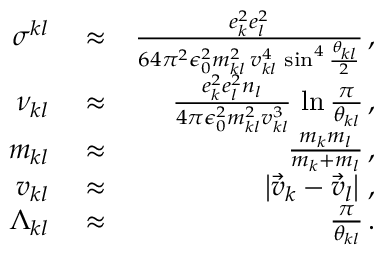<formula> <loc_0><loc_0><loc_500><loc_500>\begin{array} { r l r } { \sigma ^ { k l } } & \approx } & { \frac { e _ { k } ^ { 2 } e _ { l } ^ { 2 } } { 6 4 \pi ^ { 2 } \epsilon _ { 0 } ^ { 2 } m _ { k l } ^ { 2 } \, v _ { k l } ^ { 4 } \, \sin ^ { 4 } \frac { \theta _ { k l } } { 2 } } \, , } \\ { \nu _ { k l } } & \approx } & { \frac { e _ { k } ^ { 2 } e _ { l } ^ { 2 } n _ { l } } { 4 \pi \epsilon _ { 0 } ^ { 2 } m _ { k l } ^ { 2 } v _ { k l } ^ { 3 } } \, \ln \frac { \pi } { \theta _ { k l } } \, , } \\ { m _ { k l } } & \approx } & { \frac { m _ { k } m _ { l } } { m _ { k } + m _ { l } } \, , } \\ { v _ { k l } } & \approx } & { \left | \vec { v } _ { k } - \vec { v } _ { l } \right | \, , } \\ { \Lambda _ { k l } } & \approx } & { \frac { \pi } { \theta _ { k l } } \, . } \end{array}</formula> 